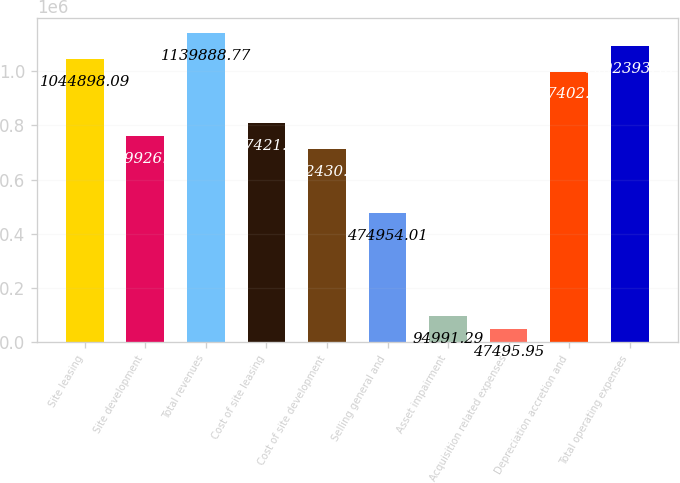Convert chart to OTSL. <chart><loc_0><loc_0><loc_500><loc_500><bar_chart><fcel>Site leasing<fcel>Site development<fcel>Total revenues<fcel>Cost of site leasing<fcel>Cost of site development<fcel>Selling general and<fcel>Asset impairment<fcel>Acquisition related expenses<fcel>Depreciation accretion and<fcel>Total operating expenses<nl><fcel>1.0449e+06<fcel>759926<fcel>1.13989e+06<fcel>807421<fcel>712431<fcel>474954<fcel>94991.3<fcel>47495.9<fcel>997403<fcel>1.09239e+06<nl></chart> 